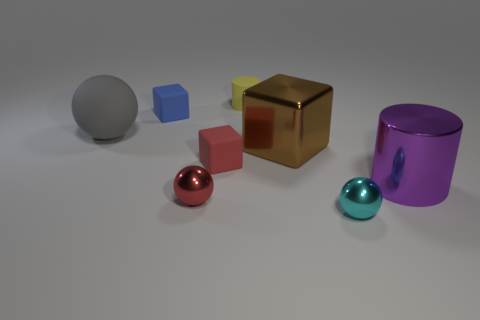Add 2 small yellow objects. How many objects exist? 10 Subtract all cylinders. How many objects are left? 6 Subtract 0 brown cylinders. How many objects are left? 8 Subtract all big brown metallic spheres. Subtract all rubber objects. How many objects are left? 4 Add 4 small red rubber cubes. How many small red rubber cubes are left? 5 Add 5 small cyan balls. How many small cyan balls exist? 6 